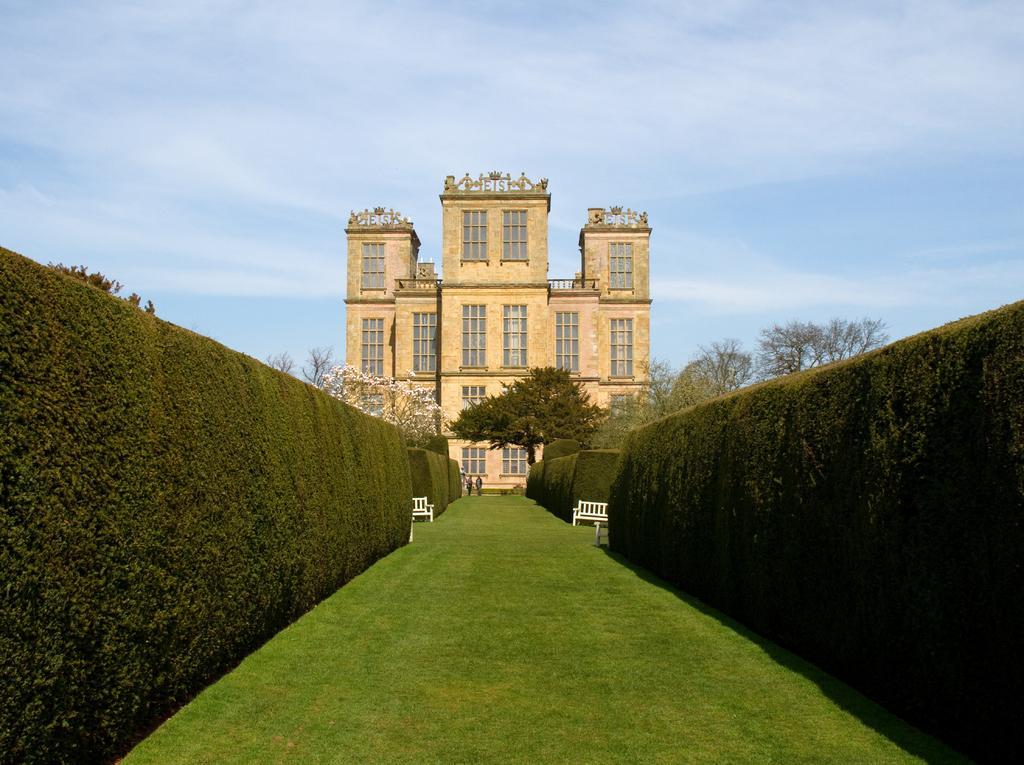Could you give a brief overview of what you see in this image? At the bottom of the picture, we see the grass. On either side of the picture, we see privet hedge plants. We see two white benched. In this picture, we see two people are standing. There are trees and a castle in the background. At the top, we see the sky. 